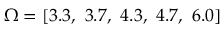<formula> <loc_0><loc_0><loc_500><loc_500>\Omega = [ 3 . 3 , 3 . 7 , 4 . 3 , 4 . 7 , 6 . 0 ]</formula> 